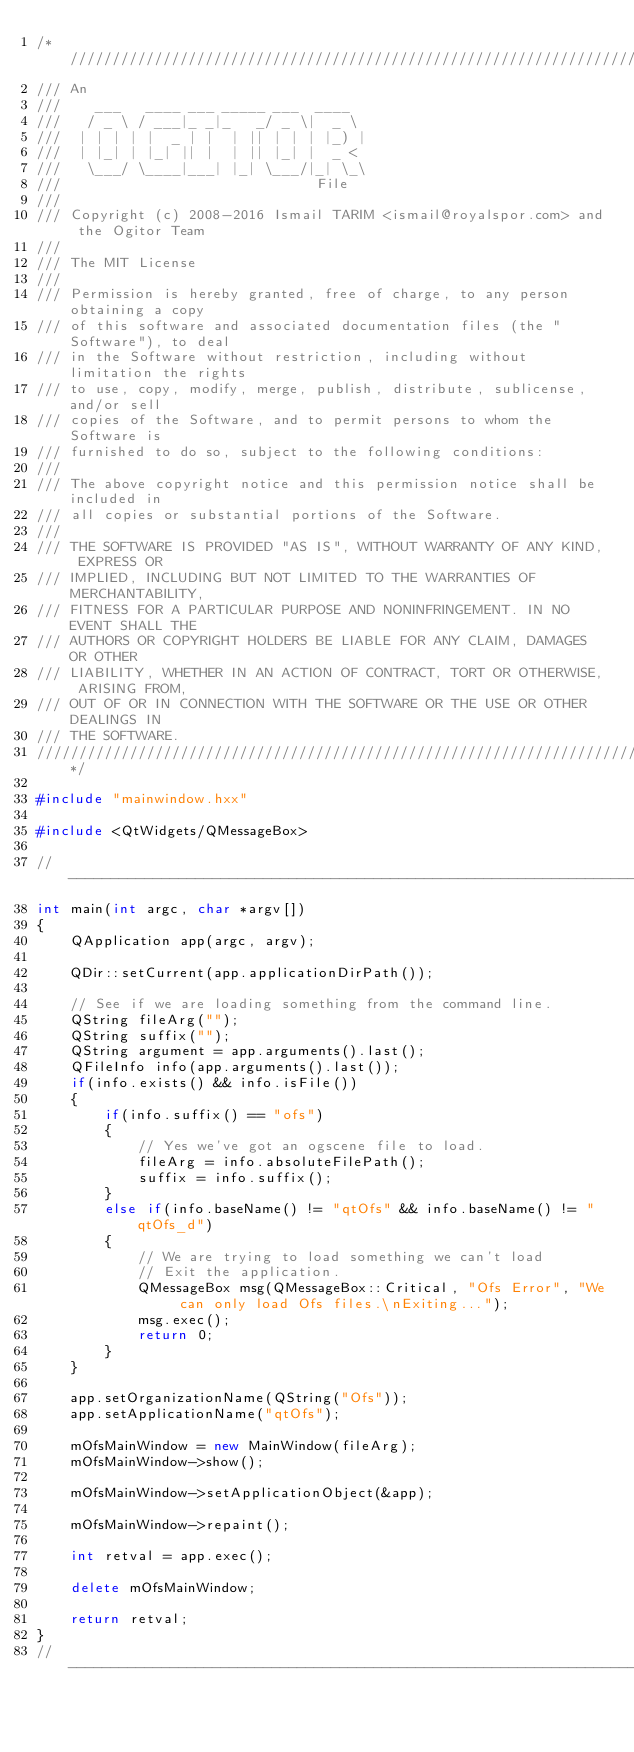<code> <loc_0><loc_0><loc_500><loc_500><_C++_>/*/////////////////////////////////////////////////////////////////////////////////
/// An
///    ___   ____ ___ _____ ___  ____
///   / _ \ / ___|_ _|_   _/ _ \|  _ \
///  | | | | |  _ | |  | || | | | |_) |
///  | |_| | |_| || |  | || |_| |  _ <
///   \___/ \____|___| |_| \___/|_| \_\
///                              File
///
/// Copyright (c) 2008-2016 Ismail TARIM <ismail@royalspor.com> and the Ogitor Team
///
/// The MIT License
///
/// Permission is hereby granted, free of charge, to any person obtaining a copy
/// of this software and associated documentation files (the "Software"), to deal
/// in the Software without restriction, including without limitation the rights
/// to use, copy, modify, merge, publish, distribute, sublicense, and/or sell
/// copies of the Software, and to permit persons to whom the Software is
/// furnished to do so, subject to the following conditions:
///
/// The above copyright notice and this permission notice shall be included in
/// all copies or substantial portions of the Software.
///
/// THE SOFTWARE IS PROVIDED "AS IS", WITHOUT WARRANTY OF ANY KIND, EXPRESS OR
/// IMPLIED, INCLUDING BUT NOT LIMITED TO THE WARRANTIES OF MERCHANTABILITY,
/// FITNESS FOR A PARTICULAR PURPOSE AND NONINFRINGEMENT. IN NO EVENT SHALL THE
/// AUTHORS OR COPYRIGHT HOLDERS BE LIABLE FOR ANY CLAIM, DAMAGES OR OTHER
/// LIABILITY, WHETHER IN AN ACTION OF CONTRACT, TORT OR OTHERWISE, ARISING FROM,
/// OUT OF OR IN CONNECTION WITH THE SOFTWARE OR THE USE OR OTHER DEALINGS IN
/// THE SOFTWARE.
////////////////////////////////////////////////////////////////////////////////*/

#include "mainwindow.hxx"

#include <QtWidgets/QMessageBox>

//-------------------------------------------------------------------------------------
int main(int argc, char *argv[])
{
    QApplication app(argc, argv);

    QDir::setCurrent(app.applicationDirPath());

    // See if we are loading something from the command line.
    QString fileArg("");
    QString suffix("");
    QString argument = app.arguments().last();
    QFileInfo info(app.arguments().last());
    if(info.exists() && info.isFile())
    {
        if(info.suffix() == "ofs")
        {
            // Yes we've got an ogscene file to load.
            fileArg = info.absoluteFilePath();
            suffix = info.suffix();
        }
        else if(info.baseName() != "qtOfs" && info.baseName() != "qtOfs_d")
        {
            // We are trying to load something we can't load
            // Exit the application.
            QMessageBox msg(QMessageBox::Critical, "Ofs Error", "We can only load Ofs files.\nExiting...");
            msg.exec();
            return 0;
        }
    }

    app.setOrganizationName(QString("Ofs"));
    app.setApplicationName("qtOfs");

    mOfsMainWindow = new MainWindow(fileArg);
    mOfsMainWindow->show();
    
    mOfsMainWindow->setApplicationObject(&app);

    mOfsMainWindow->repaint();

    int retval = app.exec();

    delete mOfsMainWindow;

    return retval;
}
//-------------------------------------------------------------------------------------
</code> 